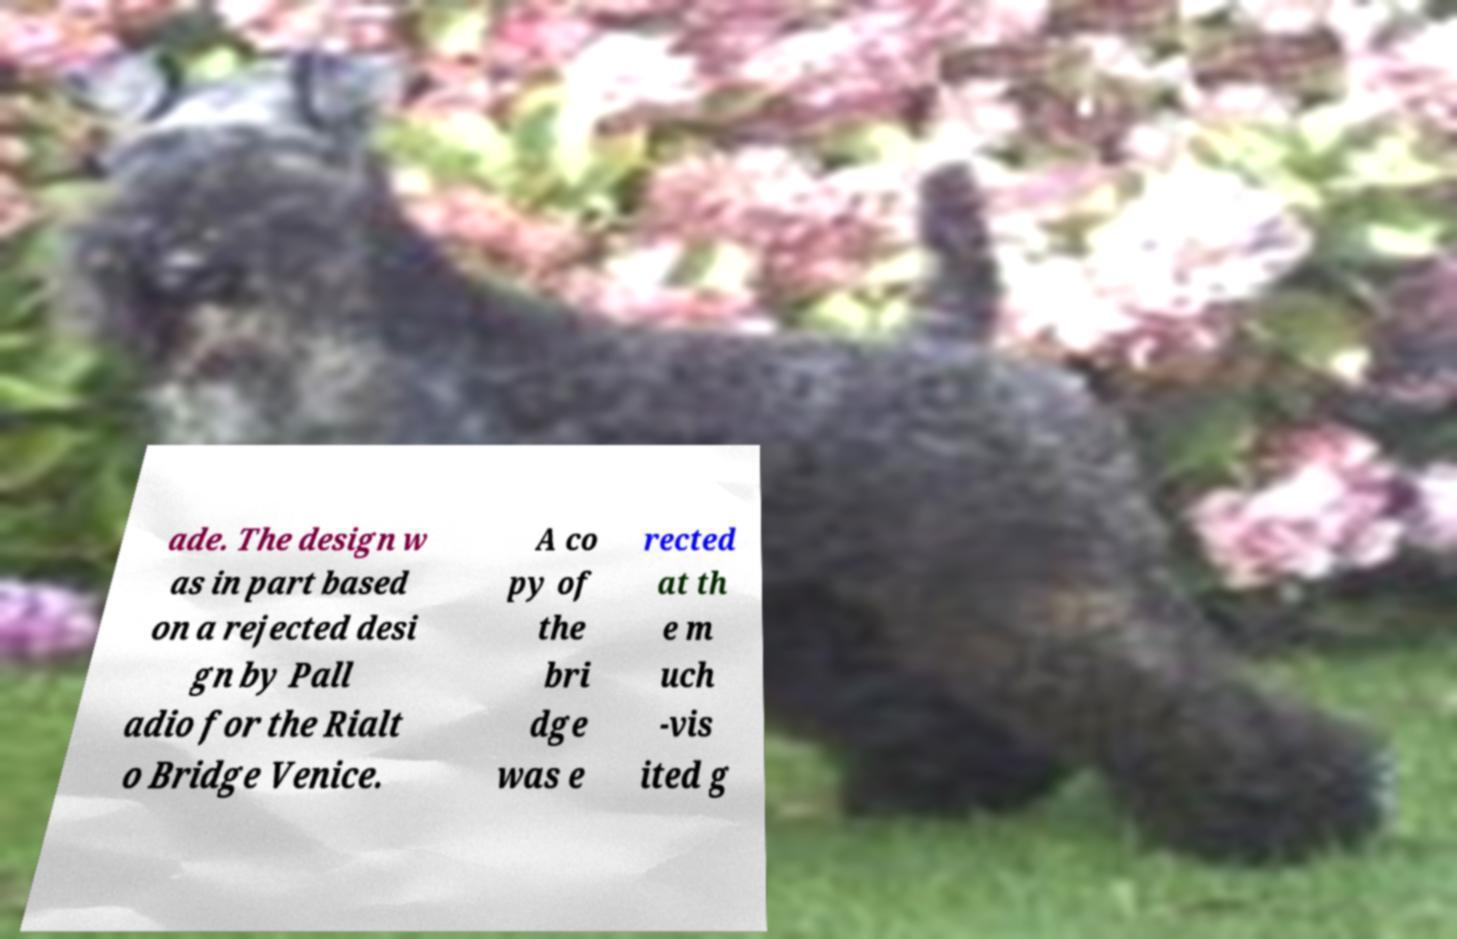I need the written content from this picture converted into text. Can you do that? ade. The design w as in part based on a rejected desi gn by Pall adio for the Rialt o Bridge Venice. A co py of the bri dge was e rected at th e m uch -vis ited g 